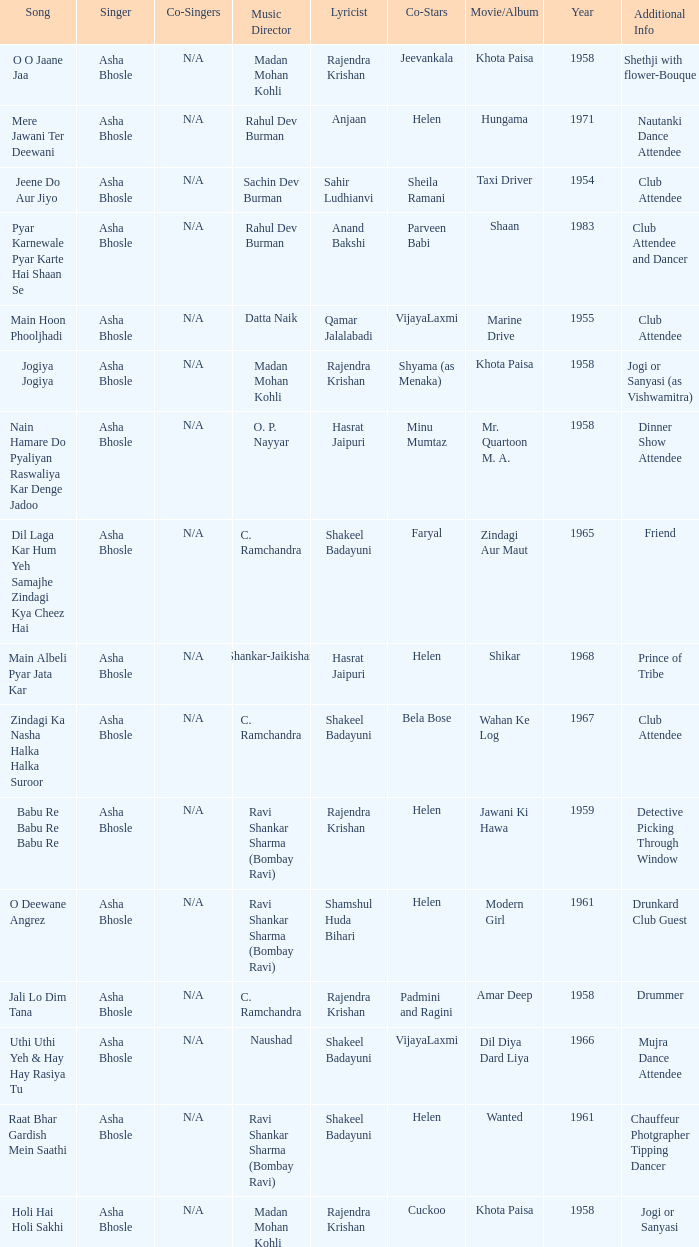What movie did Vijayalaxmi Co-star in and Shakeel Badayuni write the lyrics? Dil Diya Dard Liya. 